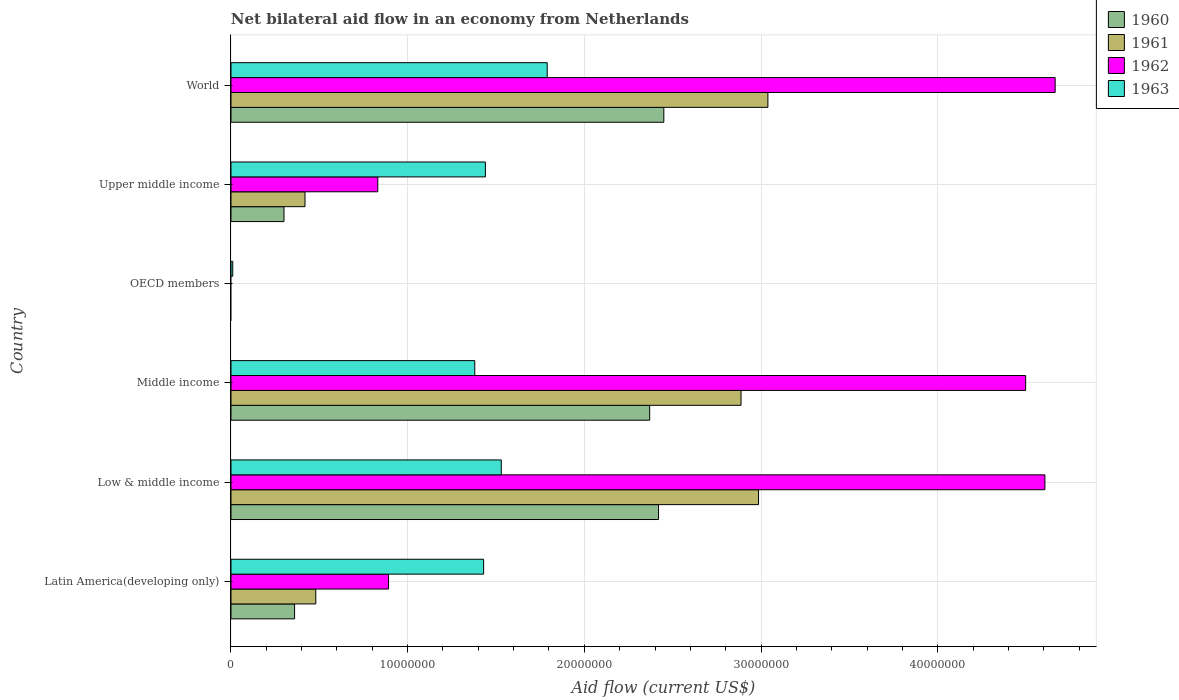Are the number of bars on each tick of the Y-axis equal?
Offer a very short reply. No. How many bars are there on the 6th tick from the top?
Make the answer very short. 4. How many bars are there on the 2nd tick from the bottom?
Keep it short and to the point. 4. What is the label of the 1st group of bars from the top?
Offer a terse response. World. What is the net bilateral aid flow in 1961 in Low & middle income?
Ensure brevity in your answer.  2.99e+07. Across all countries, what is the maximum net bilateral aid flow in 1962?
Offer a terse response. 4.66e+07. Across all countries, what is the minimum net bilateral aid flow in 1960?
Your answer should be very brief. 0. What is the total net bilateral aid flow in 1961 in the graph?
Ensure brevity in your answer.  9.81e+07. What is the difference between the net bilateral aid flow in 1963 in Middle income and that in OECD members?
Give a very brief answer. 1.37e+07. What is the difference between the net bilateral aid flow in 1963 in Upper middle income and the net bilateral aid flow in 1962 in Low & middle income?
Your answer should be very brief. -3.17e+07. What is the average net bilateral aid flow in 1963 per country?
Keep it short and to the point. 1.26e+07. What is the difference between the net bilateral aid flow in 1963 and net bilateral aid flow in 1962 in Middle income?
Your response must be concise. -3.12e+07. In how many countries, is the net bilateral aid flow in 1962 greater than 20000000 US$?
Ensure brevity in your answer.  3. What is the ratio of the net bilateral aid flow in 1960 in Low & middle income to that in Upper middle income?
Offer a very short reply. 8.07. Is the difference between the net bilateral aid flow in 1963 in Middle income and Upper middle income greater than the difference between the net bilateral aid flow in 1962 in Middle income and Upper middle income?
Provide a short and direct response. No. What is the difference between the highest and the second highest net bilateral aid flow in 1963?
Your answer should be compact. 2.60e+06. What is the difference between the highest and the lowest net bilateral aid flow in 1963?
Provide a succinct answer. 1.78e+07. Is the sum of the net bilateral aid flow in 1961 in Low & middle income and Middle income greater than the maximum net bilateral aid flow in 1960 across all countries?
Ensure brevity in your answer.  Yes. Are all the bars in the graph horizontal?
Your response must be concise. Yes. How many countries are there in the graph?
Make the answer very short. 6. What is the difference between two consecutive major ticks on the X-axis?
Your answer should be compact. 1.00e+07. Are the values on the major ticks of X-axis written in scientific E-notation?
Provide a short and direct response. No. What is the title of the graph?
Your answer should be compact. Net bilateral aid flow in an economy from Netherlands. What is the label or title of the Y-axis?
Give a very brief answer. Country. What is the Aid flow (current US$) in 1960 in Latin America(developing only)?
Make the answer very short. 3.60e+06. What is the Aid flow (current US$) of 1961 in Latin America(developing only)?
Provide a short and direct response. 4.80e+06. What is the Aid flow (current US$) in 1962 in Latin America(developing only)?
Provide a short and direct response. 8.92e+06. What is the Aid flow (current US$) of 1963 in Latin America(developing only)?
Your answer should be compact. 1.43e+07. What is the Aid flow (current US$) of 1960 in Low & middle income?
Provide a succinct answer. 2.42e+07. What is the Aid flow (current US$) of 1961 in Low & middle income?
Ensure brevity in your answer.  2.99e+07. What is the Aid flow (current US$) of 1962 in Low & middle income?
Your response must be concise. 4.61e+07. What is the Aid flow (current US$) of 1963 in Low & middle income?
Give a very brief answer. 1.53e+07. What is the Aid flow (current US$) in 1960 in Middle income?
Provide a succinct answer. 2.37e+07. What is the Aid flow (current US$) of 1961 in Middle income?
Provide a short and direct response. 2.89e+07. What is the Aid flow (current US$) of 1962 in Middle income?
Your answer should be compact. 4.50e+07. What is the Aid flow (current US$) of 1963 in Middle income?
Offer a terse response. 1.38e+07. What is the Aid flow (current US$) of 1961 in OECD members?
Make the answer very short. 0. What is the Aid flow (current US$) of 1961 in Upper middle income?
Your answer should be very brief. 4.19e+06. What is the Aid flow (current US$) in 1962 in Upper middle income?
Ensure brevity in your answer.  8.31e+06. What is the Aid flow (current US$) in 1963 in Upper middle income?
Give a very brief answer. 1.44e+07. What is the Aid flow (current US$) in 1960 in World?
Keep it short and to the point. 2.45e+07. What is the Aid flow (current US$) of 1961 in World?
Your answer should be compact. 3.04e+07. What is the Aid flow (current US$) of 1962 in World?
Provide a short and direct response. 4.66e+07. What is the Aid flow (current US$) of 1963 in World?
Keep it short and to the point. 1.79e+07. Across all countries, what is the maximum Aid flow (current US$) in 1960?
Keep it short and to the point. 2.45e+07. Across all countries, what is the maximum Aid flow (current US$) in 1961?
Make the answer very short. 3.04e+07. Across all countries, what is the maximum Aid flow (current US$) in 1962?
Provide a succinct answer. 4.66e+07. Across all countries, what is the maximum Aid flow (current US$) of 1963?
Provide a succinct answer. 1.79e+07. Across all countries, what is the minimum Aid flow (current US$) of 1960?
Keep it short and to the point. 0. Across all countries, what is the minimum Aid flow (current US$) in 1963?
Offer a very short reply. 1.00e+05. What is the total Aid flow (current US$) of 1960 in the graph?
Provide a short and direct response. 7.90e+07. What is the total Aid flow (current US$) in 1961 in the graph?
Offer a terse response. 9.81e+07. What is the total Aid flow (current US$) of 1962 in the graph?
Ensure brevity in your answer.  1.55e+08. What is the total Aid flow (current US$) of 1963 in the graph?
Provide a short and direct response. 7.58e+07. What is the difference between the Aid flow (current US$) of 1960 in Latin America(developing only) and that in Low & middle income?
Provide a short and direct response. -2.06e+07. What is the difference between the Aid flow (current US$) in 1961 in Latin America(developing only) and that in Low & middle income?
Your answer should be very brief. -2.51e+07. What is the difference between the Aid flow (current US$) in 1962 in Latin America(developing only) and that in Low & middle income?
Your response must be concise. -3.72e+07. What is the difference between the Aid flow (current US$) in 1960 in Latin America(developing only) and that in Middle income?
Your answer should be compact. -2.01e+07. What is the difference between the Aid flow (current US$) of 1961 in Latin America(developing only) and that in Middle income?
Your answer should be compact. -2.41e+07. What is the difference between the Aid flow (current US$) of 1962 in Latin America(developing only) and that in Middle income?
Provide a succinct answer. -3.61e+07. What is the difference between the Aid flow (current US$) in 1963 in Latin America(developing only) and that in Middle income?
Ensure brevity in your answer.  5.00e+05. What is the difference between the Aid flow (current US$) of 1963 in Latin America(developing only) and that in OECD members?
Ensure brevity in your answer.  1.42e+07. What is the difference between the Aid flow (current US$) in 1960 in Latin America(developing only) and that in Upper middle income?
Your response must be concise. 6.00e+05. What is the difference between the Aid flow (current US$) of 1962 in Latin America(developing only) and that in Upper middle income?
Ensure brevity in your answer.  6.10e+05. What is the difference between the Aid flow (current US$) of 1960 in Latin America(developing only) and that in World?
Your response must be concise. -2.09e+07. What is the difference between the Aid flow (current US$) of 1961 in Latin America(developing only) and that in World?
Ensure brevity in your answer.  -2.56e+07. What is the difference between the Aid flow (current US$) of 1962 in Latin America(developing only) and that in World?
Your response must be concise. -3.77e+07. What is the difference between the Aid flow (current US$) in 1963 in Latin America(developing only) and that in World?
Provide a succinct answer. -3.60e+06. What is the difference between the Aid flow (current US$) in 1961 in Low & middle income and that in Middle income?
Offer a terse response. 9.90e+05. What is the difference between the Aid flow (current US$) of 1962 in Low & middle income and that in Middle income?
Offer a terse response. 1.09e+06. What is the difference between the Aid flow (current US$) of 1963 in Low & middle income and that in Middle income?
Your response must be concise. 1.50e+06. What is the difference between the Aid flow (current US$) in 1963 in Low & middle income and that in OECD members?
Give a very brief answer. 1.52e+07. What is the difference between the Aid flow (current US$) in 1960 in Low & middle income and that in Upper middle income?
Offer a very short reply. 2.12e+07. What is the difference between the Aid flow (current US$) in 1961 in Low & middle income and that in Upper middle income?
Give a very brief answer. 2.57e+07. What is the difference between the Aid flow (current US$) in 1962 in Low & middle income and that in Upper middle income?
Your answer should be very brief. 3.78e+07. What is the difference between the Aid flow (current US$) of 1960 in Low & middle income and that in World?
Your answer should be compact. -3.00e+05. What is the difference between the Aid flow (current US$) in 1961 in Low & middle income and that in World?
Keep it short and to the point. -5.30e+05. What is the difference between the Aid flow (current US$) in 1962 in Low & middle income and that in World?
Give a very brief answer. -5.80e+05. What is the difference between the Aid flow (current US$) of 1963 in Low & middle income and that in World?
Offer a very short reply. -2.60e+06. What is the difference between the Aid flow (current US$) in 1963 in Middle income and that in OECD members?
Your answer should be very brief. 1.37e+07. What is the difference between the Aid flow (current US$) of 1960 in Middle income and that in Upper middle income?
Offer a terse response. 2.07e+07. What is the difference between the Aid flow (current US$) of 1961 in Middle income and that in Upper middle income?
Your answer should be very brief. 2.47e+07. What is the difference between the Aid flow (current US$) in 1962 in Middle income and that in Upper middle income?
Provide a short and direct response. 3.67e+07. What is the difference between the Aid flow (current US$) in 1963 in Middle income and that in Upper middle income?
Your answer should be very brief. -6.00e+05. What is the difference between the Aid flow (current US$) in 1960 in Middle income and that in World?
Offer a very short reply. -8.00e+05. What is the difference between the Aid flow (current US$) of 1961 in Middle income and that in World?
Provide a succinct answer. -1.52e+06. What is the difference between the Aid flow (current US$) in 1962 in Middle income and that in World?
Your response must be concise. -1.67e+06. What is the difference between the Aid flow (current US$) in 1963 in Middle income and that in World?
Provide a short and direct response. -4.10e+06. What is the difference between the Aid flow (current US$) of 1963 in OECD members and that in Upper middle income?
Offer a terse response. -1.43e+07. What is the difference between the Aid flow (current US$) of 1963 in OECD members and that in World?
Your response must be concise. -1.78e+07. What is the difference between the Aid flow (current US$) of 1960 in Upper middle income and that in World?
Offer a terse response. -2.15e+07. What is the difference between the Aid flow (current US$) in 1961 in Upper middle income and that in World?
Offer a very short reply. -2.62e+07. What is the difference between the Aid flow (current US$) of 1962 in Upper middle income and that in World?
Ensure brevity in your answer.  -3.83e+07. What is the difference between the Aid flow (current US$) in 1963 in Upper middle income and that in World?
Your answer should be very brief. -3.50e+06. What is the difference between the Aid flow (current US$) of 1960 in Latin America(developing only) and the Aid flow (current US$) of 1961 in Low & middle income?
Your answer should be compact. -2.63e+07. What is the difference between the Aid flow (current US$) in 1960 in Latin America(developing only) and the Aid flow (current US$) in 1962 in Low & middle income?
Your response must be concise. -4.25e+07. What is the difference between the Aid flow (current US$) of 1960 in Latin America(developing only) and the Aid flow (current US$) of 1963 in Low & middle income?
Provide a short and direct response. -1.17e+07. What is the difference between the Aid flow (current US$) in 1961 in Latin America(developing only) and the Aid flow (current US$) in 1962 in Low & middle income?
Keep it short and to the point. -4.13e+07. What is the difference between the Aid flow (current US$) of 1961 in Latin America(developing only) and the Aid flow (current US$) of 1963 in Low & middle income?
Offer a terse response. -1.05e+07. What is the difference between the Aid flow (current US$) of 1962 in Latin America(developing only) and the Aid flow (current US$) of 1963 in Low & middle income?
Your response must be concise. -6.38e+06. What is the difference between the Aid flow (current US$) of 1960 in Latin America(developing only) and the Aid flow (current US$) of 1961 in Middle income?
Make the answer very short. -2.53e+07. What is the difference between the Aid flow (current US$) of 1960 in Latin America(developing only) and the Aid flow (current US$) of 1962 in Middle income?
Keep it short and to the point. -4.14e+07. What is the difference between the Aid flow (current US$) of 1960 in Latin America(developing only) and the Aid flow (current US$) of 1963 in Middle income?
Your answer should be compact. -1.02e+07. What is the difference between the Aid flow (current US$) of 1961 in Latin America(developing only) and the Aid flow (current US$) of 1962 in Middle income?
Your response must be concise. -4.02e+07. What is the difference between the Aid flow (current US$) of 1961 in Latin America(developing only) and the Aid flow (current US$) of 1963 in Middle income?
Give a very brief answer. -9.00e+06. What is the difference between the Aid flow (current US$) in 1962 in Latin America(developing only) and the Aid flow (current US$) in 1963 in Middle income?
Ensure brevity in your answer.  -4.88e+06. What is the difference between the Aid flow (current US$) in 1960 in Latin America(developing only) and the Aid flow (current US$) in 1963 in OECD members?
Your answer should be compact. 3.50e+06. What is the difference between the Aid flow (current US$) of 1961 in Latin America(developing only) and the Aid flow (current US$) of 1963 in OECD members?
Make the answer very short. 4.70e+06. What is the difference between the Aid flow (current US$) of 1962 in Latin America(developing only) and the Aid flow (current US$) of 1963 in OECD members?
Give a very brief answer. 8.82e+06. What is the difference between the Aid flow (current US$) of 1960 in Latin America(developing only) and the Aid flow (current US$) of 1961 in Upper middle income?
Provide a succinct answer. -5.90e+05. What is the difference between the Aid flow (current US$) of 1960 in Latin America(developing only) and the Aid flow (current US$) of 1962 in Upper middle income?
Your answer should be compact. -4.71e+06. What is the difference between the Aid flow (current US$) in 1960 in Latin America(developing only) and the Aid flow (current US$) in 1963 in Upper middle income?
Offer a terse response. -1.08e+07. What is the difference between the Aid flow (current US$) in 1961 in Latin America(developing only) and the Aid flow (current US$) in 1962 in Upper middle income?
Make the answer very short. -3.51e+06. What is the difference between the Aid flow (current US$) in 1961 in Latin America(developing only) and the Aid flow (current US$) in 1963 in Upper middle income?
Offer a terse response. -9.60e+06. What is the difference between the Aid flow (current US$) of 1962 in Latin America(developing only) and the Aid flow (current US$) of 1963 in Upper middle income?
Give a very brief answer. -5.48e+06. What is the difference between the Aid flow (current US$) in 1960 in Latin America(developing only) and the Aid flow (current US$) in 1961 in World?
Your answer should be very brief. -2.68e+07. What is the difference between the Aid flow (current US$) in 1960 in Latin America(developing only) and the Aid flow (current US$) in 1962 in World?
Your answer should be very brief. -4.30e+07. What is the difference between the Aid flow (current US$) of 1960 in Latin America(developing only) and the Aid flow (current US$) of 1963 in World?
Offer a terse response. -1.43e+07. What is the difference between the Aid flow (current US$) in 1961 in Latin America(developing only) and the Aid flow (current US$) in 1962 in World?
Keep it short and to the point. -4.18e+07. What is the difference between the Aid flow (current US$) of 1961 in Latin America(developing only) and the Aid flow (current US$) of 1963 in World?
Offer a very short reply. -1.31e+07. What is the difference between the Aid flow (current US$) in 1962 in Latin America(developing only) and the Aid flow (current US$) in 1963 in World?
Provide a short and direct response. -8.98e+06. What is the difference between the Aid flow (current US$) of 1960 in Low & middle income and the Aid flow (current US$) of 1961 in Middle income?
Offer a very short reply. -4.67e+06. What is the difference between the Aid flow (current US$) in 1960 in Low & middle income and the Aid flow (current US$) in 1962 in Middle income?
Make the answer very short. -2.08e+07. What is the difference between the Aid flow (current US$) in 1960 in Low & middle income and the Aid flow (current US$) in 1963 in Middle income?
Keep it short and to the point. 1.04e+07. What is the difference between the Aid flow (current US$) of 1961 in Low & middle income and the Aid flow (current US$) of 1962 in Middle income?
Provide a succinct answer. -1.51e+07. What is the difference between the Aid flow (current US$) in 1961 in Low & middle income and the Aid flow (current US$) in 1963 in Middle income?
Offer a terse response. 1.61e+07. What is the difference between the Aid flow (current US$) of 1962 in Low & middle income and the Aid flow (current US$) of 1963 in Middle income?
Give a very brief answer. 3.23e+07. What is the difference between the Aid flow (current US$) of 1960 in Low & middle income and the Aid flow (current US$) of 1963 in OECD members?
Provide a succinct answer. 2.41e+07. What is the difference between the Aid flow (current US$) of 1961 in Low & middle income and the Aid flow (current US$) of 1963 in OECD members?
Your answer should be very brief. 2.98e+07. What is the difference between the Aid flow (current US$) of 1962 in Low & middle income and the Aid flow (current US$) of 1963 in OECD members?
Give a very brief answer. 4.60e+07. What is the difference between the Aid flow (current US$) of 1960 in Low & middle income and the Aid flow (current US$) of 1961 in Upper middle income?
Offer a terse response. 2.00e+07. What is the difference between the Aid flow (current US$) of 1960 in Low & middle income and the Aid flow (current US$) of 1962 in Upper middle income?
Your answer should be very brief. 1.59e+07. What is the difference between the Aid flow (current US$) in 1960 in Low & middle income and the Aid flow (current US$) in 1963 in Upper middle income?
Give a very brief answer. 9.80e+06. What is the difference between the Aid flow (current US$) in 1961 in Low & middle income and the Aid flow (current US$) in 1962 in Upper middle income?
Offer a very short reply. 2.16e+07. What is the difference between the Aid flow (current US$) in 1961 in Low & middle income and the Aid flow (current US$) in 1963 in Upper middle income?
Your answer should be compact. 1.55e+07. What is the difference between the Aid flow (current US$) of 1962 in Low & middle income and the Aid flow (current US$) of 1963 in Upper middle income?
Make the answer very short. 3.17e+07. What is the difference between the Aid flow (current US$) of 1960 in Low & middle income and the Aid flow (current US$) of 1961 in World?
Keep it short and to the point. -6.19e+06. What is the difference between the Aid flow (current US$) of 1960 in Low & middle income and the Aid flow (current US$) of 1962 in World?
Provide a succinct answer. -2.24e+07. What is the difference between the Aid flow (current US$) in 1960 in Low & middle income and the Aid flow (current US$) in 1963 in World?
Your response must be concise. 6.30e+06. What is the difference between the Aid flow (current US$) of 1961 in Low & middle income and the Aid flow (current US$) of 1962 in World?
Offer a very short reply. -1.68e+07. What is the difference between the Aid flow (current US$) of 1961 in Low & middle income and the Aid flow (current US$) of 1963 in World?
Your response must be concise. 1.20e+07. What is the difference between the Aid flow (current US$) of 1962 in Low & middle income and the Aid flow (current US$) of 1963 in World?
Your answer should be very brief. 2.82e+07. What is the difference between the Aid flow (current US$) in 1960 in Middle income and the Aid flow (current US$) in 1963 in OECD members?
Offer a terse response. 2.36e+07. What is the difference between the Aid flow (current US$) in 1961 in Middle income and the Aid flow (current US$) in 1963 in OECD members?
Offer a very short reply. 2.88e+07. What is the difference between the Aid flow (current US$) in 1962 in Middle income and the Aid flow (current US$) in 1963 in OECD members?
Offer a terse response. 4.49e+07. What is the difference between the Aid flow (current US$) in 1960 in Middle income and the Aid flow (current US$) in 1961 in Upper middle income?
Your answer should be compact. 1.95e+07. What is the difference between the Aid flow (current US$) in 1960 in Middle income and the Aid flow (current US$) in 1962 in Upper middle income?
Keep it short and to the point. 1.54e+07. What is the difference between the Aid flow (current US$) of 1960 in Middle income and the Aid flow (current US$) of 1963 in Upper middle income?
Your answer should be compact. 9.30e+06. What is the difference between the Aid flow (current US$) in 1961 in Middle income and the Aid flow (current US$) in 1962 in Upper middle income?
Ensure brevity in your answer.  2.06e+07. What is the difference between the Aid flow (current US$) of 1961 in Middle income and the Aid flow (current US$) of 1963 in Upper middle income?
Make the answer very short. 1.45e+07. What is the difference between the Aid flow (current US$) in 1962 in Middle income and the Aid flow (current US$) in 1963 in Upper middle income?
Provide a short and direct response. 3.06e+07. What is the difference between the Aid flow (current US$) in 1960 in Middle income and the Aid flow (current US$) in 1961 in World?
Give a very brief answer. -6.69e+06. What is the difference between the Aid flow (current US$) in 1960 in Middle income and the Aid flow (current US$) in 1962 in World?
Offer a terse response. -2.30e+07. What is the difference between the Aid flow (current US$) in 1960 in Middle income and the Aid flow (current US$) in 1963 in World?
Keep it short and to the point. 5.80e+06. What is the difference between the Aid flow (current US$) in 1961 in Middle income and the Aid flow (current US$) in 1962 in World?
Your answer should be compact. -1.78e+07. What is the difference between the Aid flow (current US$) in 1961 in Middle income and the Aid flow (current US$) in 1963 in World?
Offer a terse response. 1.10e+07. What is the difference between the Aid flow (current US$) of 1962 in Middle income and the Aid flow (current US$) of 1963 in World?
Offer a very short reply. 2.71e+07. What is the difference between the Aid flow (current US$) in 1960 in Upper middle income and the Aid flow (current US$) in 1961 in World?
Ensure brevity in your answer.  -2.74e+07. What is the difference between the Aid flow (current US$) in 1960 in Upper middle income and the Aid flow (current US$) in 1962 in World?
Make the answer very short. -4.36e+07. What is the difference between the Aid flow (current US$) of 1960 in Upper middle income and the Aid flow (current US$) of 1963 in World?
Give a very brief answer. -1.49e+07. What is the difference between the Aid flow (current US$) in 1961 in Upper middle income and the Aid flow (current US$) in 1962 in World?
Offer a very short reply. -4.25e+07. What is the difference between the Aid flow (current US$) in 1961 in Upper middle income and the Aid flow (current US$) in 1963 in World?
Provide a succinct answer. -1.37e+07. What is the difference between the Aid flow (current US$) in 1962 in Upper middle income and the Aid flow (current US$) in 1963 in World?
Provide a succinct answer. -9.59e+06. What is the average Aid flow (current US$) of 1960 per country?
Keep it short and to the point. 1.32e+07. What is the average Aid flow (current US$) in 1961 per country?
Make the answer very short. 1.64e+07. What is the average Aid flow (current US$) of 1962 per country?
Keep it short and to the point. 2.58e+07. What is the average Aid flow (current US$) of 1963 per country?
Keep it short and to the point. 1.26e+07. What is the difference between the Aid flow (current US$) in 1960 and Aid flow (current US$) in 1961 in Latin America(developing only)?
Offer a very short reply. -1.20e+06. What is the difference between the Aid flow (current US$) of 1960 and Aid flow (current US$) of 1962 in Latin America(developing only)?
Give a very brief answer. -5.32e+06. What is the difference between the Aid flow (current US$) of 1960 and Aid flow (current US$) of 1963 in Latin America(developing only)?
Provide a succinct answer. -1.07e+07. What is the difference between the Aid flow (current US$) in 1961 and Aid flow (current US$) in 1962 in Latin America(developing only)?
Your response must be concise. -4.12e+06. What is the difference between the Aid flow (current US$) of 1961 and Aid flow (current US$) of 1963 in Latin America(developing only)?
Give a very brief answer. -9.50e+06. What is the difference between the Aid flow (current US$) of 1962 and Aid flow (current US$) of 1963 in Latin America(developing only)?
Your answer should be compact. -5.38e+06. What is the difference between the Aid flow (current US$) of 1960 and Aid flow (current US$) of 1961 in Low & middle income?
Keep it short and to the point. -5.66e+06. What is the difference between the Aid flow (current US$) in 1960 and Aid flow (current US$) in 1962 in Low & middle income?
Offer a terse response. -2.19e+07. What is the difference between the Aid flow (current US$) of 1960 and Aid flow (current US$) of 1963 in Low & middle income?
Offer a very short reply. 8.90e+06. What is the difference between the Aid flow (current US$) in 1961 and Aid flow (current US$) in 1962 in Low & middle income?
Your response must be concise. -1.62e+07. What is the difference between the Aid flow (current US$) of 1961 and Aid flow (current US$) of 1963 in Low & middle income?
Offer a terse response. 1.46e+07. What is the difference between the Aid flow (current US$) in 1962 and Aid flow (current US$) in 1963 in Low & middle income?
Provide a short and direct response. 3.08e+07. What is the difference between the Aid flow (current US$) in 1960 and Aid flow (current US$) in 1961 in Middle income?
Ensure brevity in your answer.  -5.17e+06. What is the difference between the Aid flow (current US$) of 1960 and Aid flow (current US$) of 1962 in Middle income?
Make the answer very short. -2.13e+07. What is the difference between the Aid flow (current US$) of 1960 and Aid flow (current US$) of 1963 in Middle income?
Keep it short and to the point. 9.90e+06. What is the difference between the Aid flow (current US$) in 1961 and Aid flow (current US$) in 1962 in Middle income?
Your answer should be compact. -1.61e+07. What is the difference between the Aid flow (current US$) of 1961 and Aid flow (current US$) of 1963 in Middle income?
Provide a succinct answer. 1.51e+07. What is the difference between the Aid flow (current US$) in 1962 and Aid flow (current US$) in 1963 in Middle income?
Make the answer very short. 3.12e+07. What is the difference between the Aid flow (current US$) in 1960 and Aid flow (current US$) in 1961 in Upper middle income?
Provide a succinct answer. -1.19e+06. What is the difference between the Aid flow (current US$) of 1960 and Aid flow (current US$) of 1962 in Upper middle income?
Ensure brevity in your answer.  -5.31e+06. What is the difference between the Aid flow (current US$) in 1960 and Aid flow (current US$) in 1963 in Upper middle income?
Offer a very short reply. -1.14e+07. What is the difference between the Aid flow (current US$) of 1961 and Aid flow (current US$) of 1962 in Upper middle income?
Provide a succinct answer. -4.12e+06. What is the difference between the Aid flow (current US$) in 1961 and Aid flow (current US$) in 1963 in Upper middle income?
Your answer should be compact. -1.02e+07. What is the difference between the Aid flow (current US$) of 1962 and Aid flow (current US$) of 1963 in Upper middle income?
Your response must be concise. -6.09e+06. What is the difference between the Aid flow (current US$) in 1960 and Aid flow (current US$) in 1961 in World?
Your response must be concise. -5.89e+06. What is the difference between the Aid flow (current US$) of 1960 and Aid flow (current US$) of 1962 in World?
Provide a short and direct response. -2.22e+07. What is the difference between the Aid flow (current US$) in 1960 and Aid flow (current US$) in 1963 in World?
Your answer should be very brief. 6.60e+06. What is the difference between the Aid flow (current US$) of 1961 and Aid flow (current US$) of 1962 in World?
Give a very brief answer. -1.63e+07. What is the difference between the Aid flow (current US$) in 1961 and Aid flow (current US$) in 1963 in World?
Keep it short and to the point. 1.25e+07. What is the difference between the Aid flow (current US$) of 1962 and Aid flow (current US$) of 1963 in World?
Ensure brevity in your answer.  2.88e+07. What is the ratio of the Aid flow (current US$) of 1960 in Latin America(developing only) to that in Low & middle income?
Keep it short and to the point. 0.15. What is the ratio of the Aid flow (current US$) of 1961 in Latin America(developing only) to that in Low & middle income?
Provide a succinct answer. 0.16. What is the ratio of the Aid flow (current US$) of 1962 in Latin America(developing only) to that in Low & middle income?
Provide a succinct answer. 0.19. What is the ratio of the Aid flow (current US$) in 1963 in Latin America(developing only) to that in Low & middle income?
Offer a terse response. 0.93. What is the ratio of the Aid flow (current US$) in 1960 in Latin America(developing only) to that in Middle income?
Provide a succinct answer. 0.15. What is the ratio of the Aid flow (current US$) of 1961 in Latin America(developing only) to that in Middle income?
Offer a very short reply. 0.17. What is the ratio of the Aid flow (current US$) of 1962 in Latin America(developing only) to that in Middle income?
Provide a succinct answer. 0.2. What is the ratio of the Aid flow (current US$) in 1963 in Latin America(developing only) to that in Middle income?
Your response must be concise. 1.04. What is the ratio of the Aid flow (current US$) of 1963 in Latin America(developing only) to that in OECD members?
Your response must be concise. 143. What is the ratio of the Aid flow (current US$) of 1960 in Latin America(developing only) to that in Upper middle income?
Provide a short and direct response. 1.2. What is the ratio of the Aid flow (current US$) in 1961 in Latin America(developing only) to that in Upper middle income?
Your answer should be compact. 1.15. What is the ratio of the Aid flow (current US$) in 1962 in Latin America(developing only) to that in Upper middle income?
Keep it short and to the point. 1.07. What is the ratio of the Aid flow (current US$) of 1960 in Latin America(developing only) to that in World?
Provide a succinct answer. 0.15. What is the ratio of the Aid flow (current US$) of 1961 in Latin America(developing only) to that in World?
Your answer should be very brief. 0.16. What is the ratio of the Aid flow (current US$) of 1962 in Latin America(developing only) to that in World?
Provide a succinct answer. 0.19. What is the ratio of the Aid flow (current US$) in 1963 in Latin America(developing only) to that in World?
Your answer should be compact. 0.8. What is the ratio of the Aid flow (current US$) of 1960 in Low & middle income to that in Middle income?
Provide a succinct answer. 1.02. What is the ratio of the Aid flow (current US$) in 1961 in Low & middle income to that in Middle income?
Your response must be concise. 1.03. What is the ratio of the Aid flow (current US$) in 1962 in Low & middle income to that in Middle income?
Keep it short and to the point. 1.02. What is the ratio of the Aid flow (current US$) in 1963 in Low & middle income to that in Middle income?
Keep it short and to the point. 1.11. What is the ratio of the Aid flow (current US$) in 1963 in Low & middle income to that in OECD members?
Give a very brief answer. 153. What is the ratio of the Aid flow (current US$) of 1960 in Low & middle income to that in Upper middle income?
Your answer should be very brief. 8.07. What is the ratio of the Aid flow (current US$) in 1961 in Low & middle income to that in Upper middle income?
Your answer should be compact. 7.13. What is the ratio of the Aid flow (current US$) of 1962 in Low & middle income to that in Upper middle income?
Your answer should be compact. 5.54. What is the ratio of the Aid flow (current US$) of 1963 in Low & middle income to that in Upper middle income?
Your answer should be compact. 1.06. What is the ratio of the Aid flow (current US$) of 1960 in Low & middle income to that in World?
Offer a terse response. 0.99. What is the ratio of the Aid flow (current US$) in 1961 in Low & middle income to that in World?
Keep it short and to the point. 0.98. What is the ratio of the Aid flow (current US$) of 1962 in Low & middle income to that in World?
Ensure brevity in your answer.  0.99. What is the ratio of the Aid flow (current US$) of 1963 in Low & middle income to that in World?
Give a very brief answer. 0.85. What is the ratio of the Aid flow (current US$) in 1963 in Middle income to that in OECD members?
Offer a terse response. 138. What is the ratio of the Aid flow (current US$) of 1960 in Middle income to that in Upper middle income?
Ensure brevity in your answer.  7.9. What is the ratio of the Aid flow (current US$) of 1961 in Middle income to that in Upper middle income?
Ensure brevity in your answer.  6.89. What is the ratio of the Aid flow (current US$) of 1962 in Middle income to that in Upper middle income?
Your answer should be compact. 5.41. What is the ratio of the Aid flow (current US$) in 1963 in Middle income to that in Upper middle income?
Provide a succinct answer. 0.96. What is the ratio of the Aid flow (current US$) in 1960 in Middle income to that in World?
Offer a terse response. 0.97. What is the ratio of the Aid flow (current US$) of 1962 in Middle income to that in World?
Provide a short and direct response. 0.96. What is the ratio of the Aid flow (current US$) of 1963 in Middle income to that in World?
Your answer should be very brief. 0.77. What is the ratio of the Aid flow (current US$) in 1963 in OECD members to that in Upper middle income?
Your answer should be compact. 0.01. What is the ratio of the Aid flow (current US$) in 1963 in OECD members to that in World?
Offer a terse response. 0.01. What is the ratio of the Aid flow (current US$) in 1960 in Upper middle income to that in World?
Your response must be concise. 0.12. What is the ratio of the Aid flow (current US$) in 1961 in Upper middle income to that in World?
Your answer should be very brief. 0.14. What is the ratio of the Aid flow (current US$) in 1962 in Upper middle income to that in World?
Your answer should be compact. 0.18. What is the ratio of the Aid flow (current US$) of 1963 in Upper middle income to that in World?
Keep it short and to the point. 0.8. What is the difference between the highest and the second highest Aid flow (current US$) of 1960?
Keep it short and to the point. 3.00e+05. What is the difference between the highest and the second highest Aid flow (current US$) of 1961?
Your answer should be very brief. 5.30e+05. What is the difference between the highest and the second highest Aid flow (current US$) of 1962?
Ensure brevity in your answer.  5.80e+05. What is the difference between the highest and the second highest Aid flow (current US$) of 1963?
Give a very brief answer. 2.60e+06. What is the difference between the highest and the lowest Aid flow (current US$) of 1960?
Make the answer very short. 2.45e+07. What is the difference between the highest and the lowest Aid flow (current US$) in 1961?
Offer a terse response. 3.04e+07. What is the difference between the highest and the lowest Aid flow (current US$) of 1962?
Make the answer very short. 4.66e+07. What is the difference between the highest and the lowest Aid flow (current US$) of 1963?
Make the answer very short. 1.78e+07. 